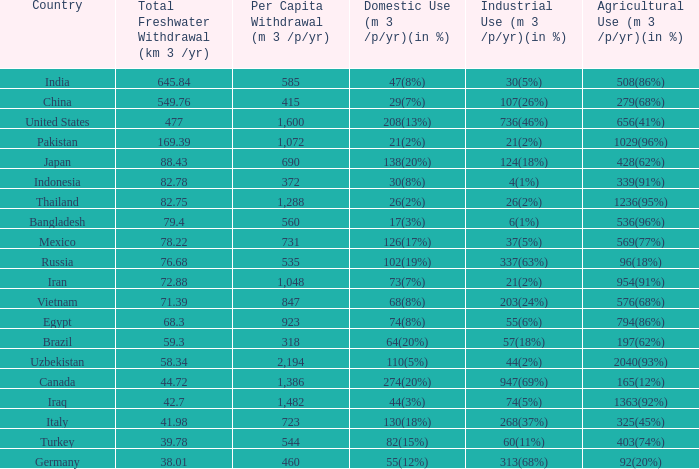What is Industrial Use (m 3 /p/yr)(in %), when Total Freshwater Withdrawal (km 3/yr) is less than 82.75, and when Agricultural Use (m 3 /p/yr)(in %) is 1363(92%)? 74(5%). 